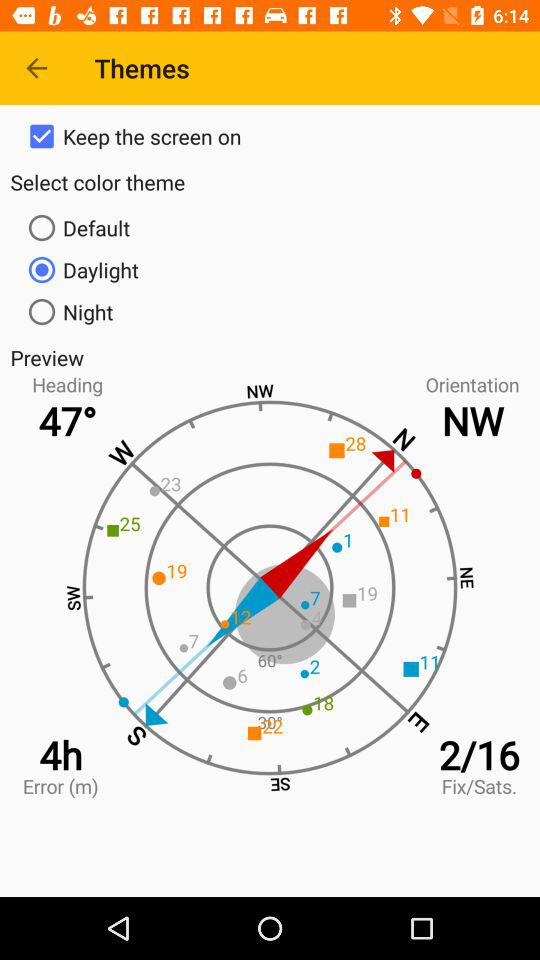What is the selected color theme? The selected color theme is "Daylight". 